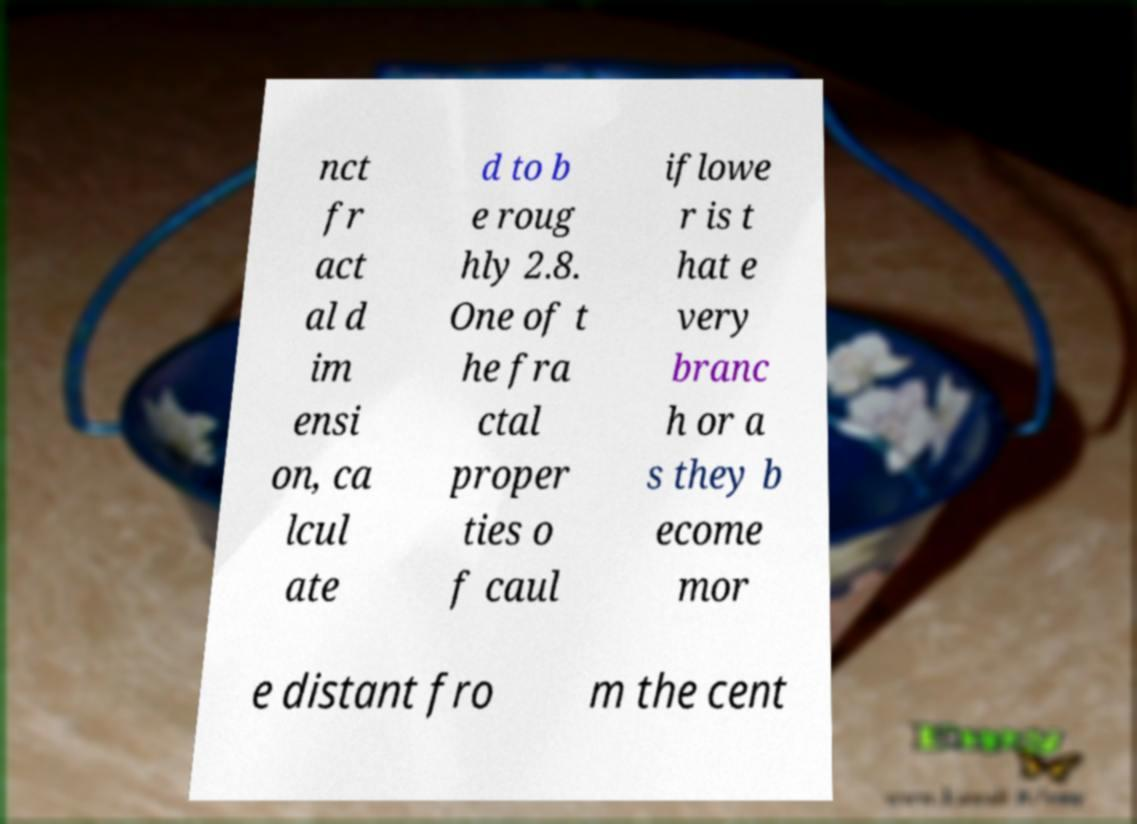Can you accurately transcribe the text from the provided image for me? nct fr act al d im ensi on, ca lcul ate d to b e roug hly 2.8. One of t he fra ctal proper ties o f caul iflowe r is t hat e very branc h or a s they b ecome mor e distant fro m the cent 